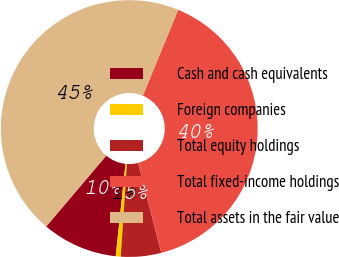Convert chart to OTSL. <chart><loc_0><loc_0><loc_500><loc_500><pie_chart><fcel>Cash and cash equivalents<fcel>Foreign companies<fcel>Total equity holdings<fcel>Total fixed-income holdings<fcel>Total assets in the fair value<nl><fcel>9.51%<fcel>0.63%<fcel>5.07%<fcel>39.77%<fcel>45.03%<nl></chart> 